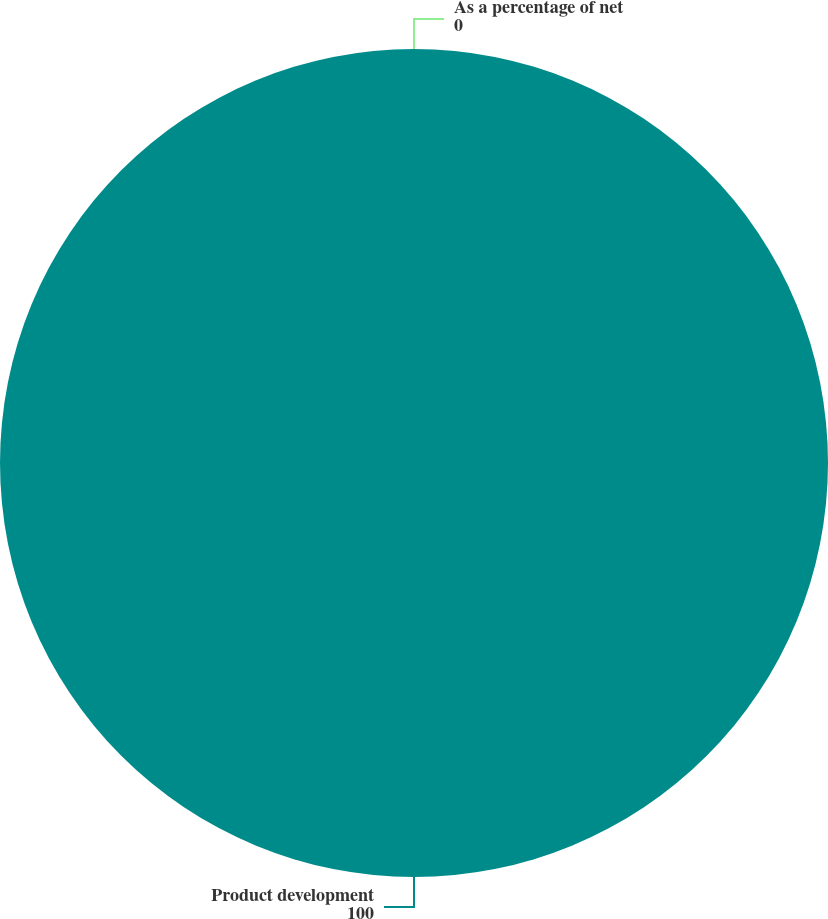<chart> <loc_0><loc_0><loc_500><loc_500><pie_chart><fcel>Product development<fcel>As a percentage of net<nl><fcel>100.0%<fcel>0.0%<nl></chart> 